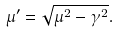<formula> <loc_0><loc_0><loc_500><loc_500>\mu ^ { \prime } = \sqrt { \mu ^ { 2 } - \gamma ^ { 2 } } .</formula> 